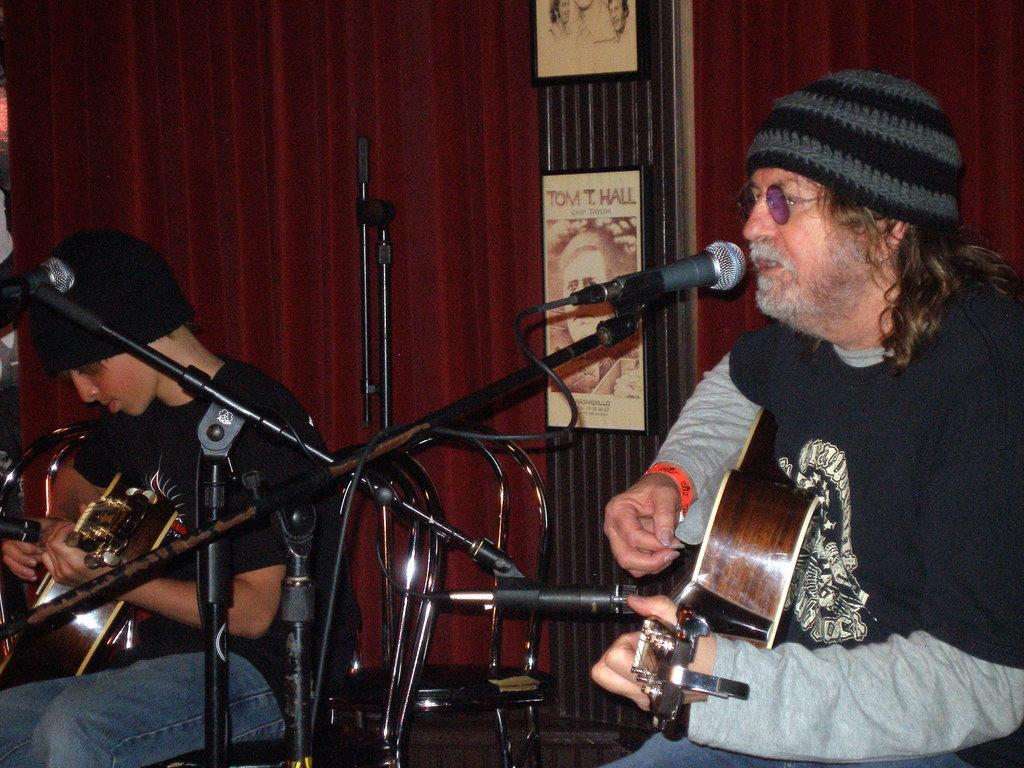How many people are in the image? There are two persons in the image. What are the persons doing in the image? The persons are sitting on chairs and playing musical instruments. What objects are present in the image that might be used for amplifying sound? There are microphones (mikes) in the image. What type of fruit is being used as a writing tool by the writer in the image? There is no writer or fruit present in the image. Where is the station located in the image? There is no station present in the image. 